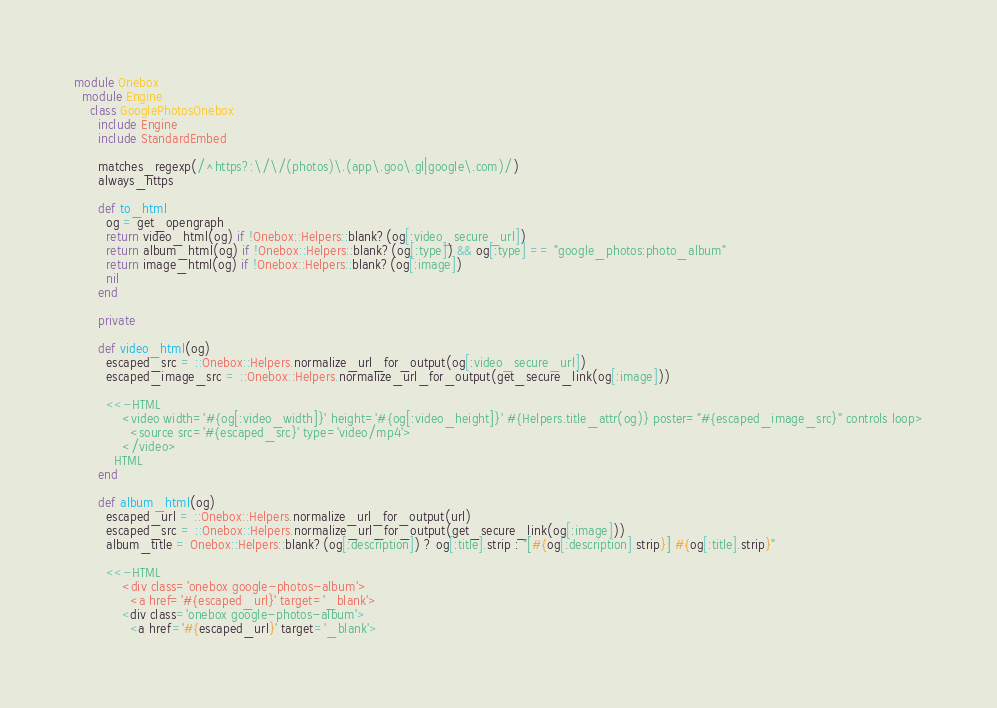<code> <loc_0><loc_0><loc_500><loc_500><_Ruby_>module Onebox
  module Engine
    class GooglePhotosOnebox
      include Engine
      include StandardEmbed

      matches_regexp(/^https?:\/\/(photos)\.(app\.goo\.gl|google\.com)/)
      always_https

      def to_html
        og = get_opengraph
        return video_html(og) if !Onebox::Helpers::blank?(og[:video_secure_url])
        return album_html(og) if !Onebox::Helpers::blank?(og[:type]) && og[:type] == "google_photos:photo_album"
        return image_html(og) if !Onebox::Helpers::blank?(og[:image])
        nil
      end

      private

      def video_html(og)
        escaped_src = ::Onebox::Helpers.normalize_url_for_output(og[:video_secure_url])
        escaped_image_src = ::Onebox::Helpers.normalize_url_for_output(get_secure_link(og[:image]))

        <<-HTML
            <video width='#{og[:video_width]}' height='#{og[:video_height]}' #{Helpers.title_attr(og)} poster="#{escaped_image_src}" controls loop>
              <source src='#{escaped_src}' type='video/mp4'>
            </video>
          HTML
      end

      def album_html(og)
        escaped_url = ::Onebox::Helpers.normalize_url_for_output(url)
        escaped_src = ::Onebox::Helpers.normalize_url_for_output(get_secure_link(og[:image]))
        album_title = Onebox::Helpers::blank?(og[:description]) ? og[:title].strip : "[#{og[:description].strip}] #{og[:title].strip}"

        <<-HTML
            <div class='onebox google-photos-album'>
              <a href='#{escaped_url}' target='_blank'></code> 